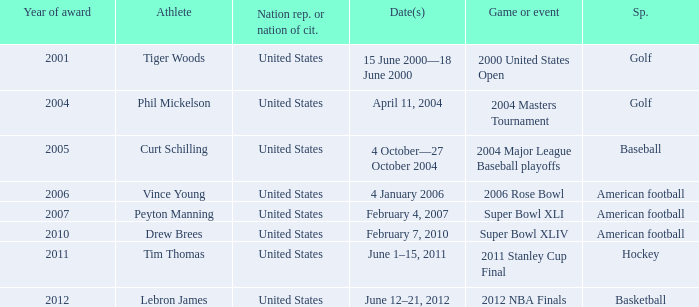In 2011 which sport had the year award? Hockey. 